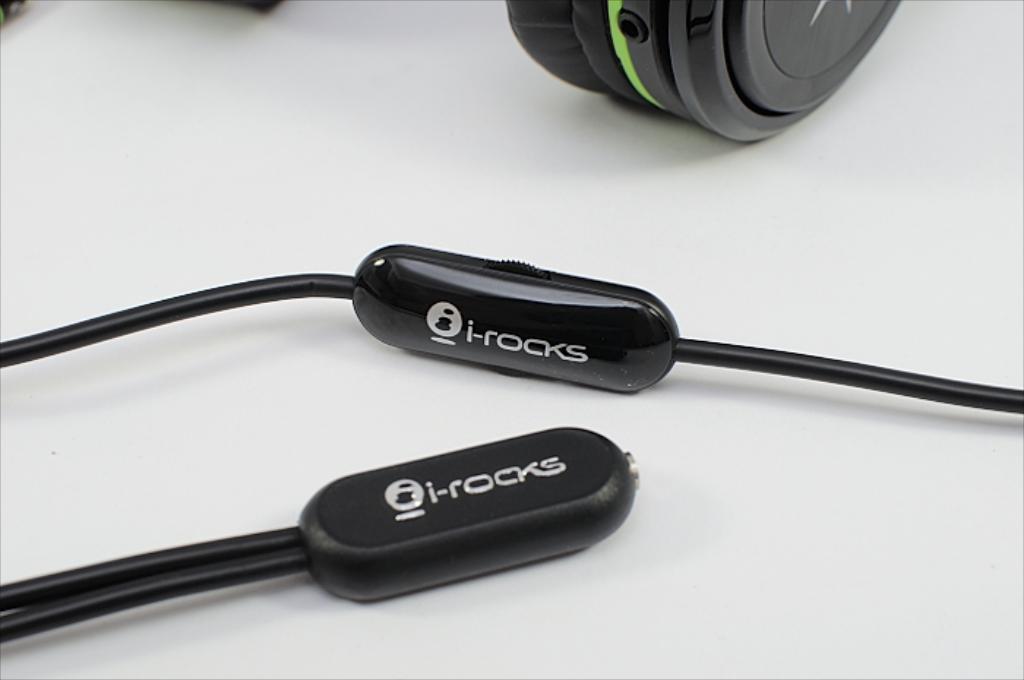Who makes the earphones?
Your answer should be compact. I-rocks. What letter is in the brand logo?
Your answer should be compact. I. 